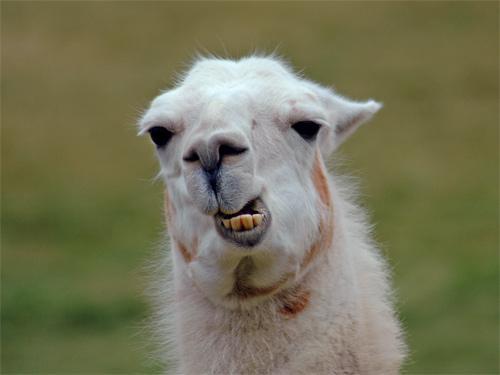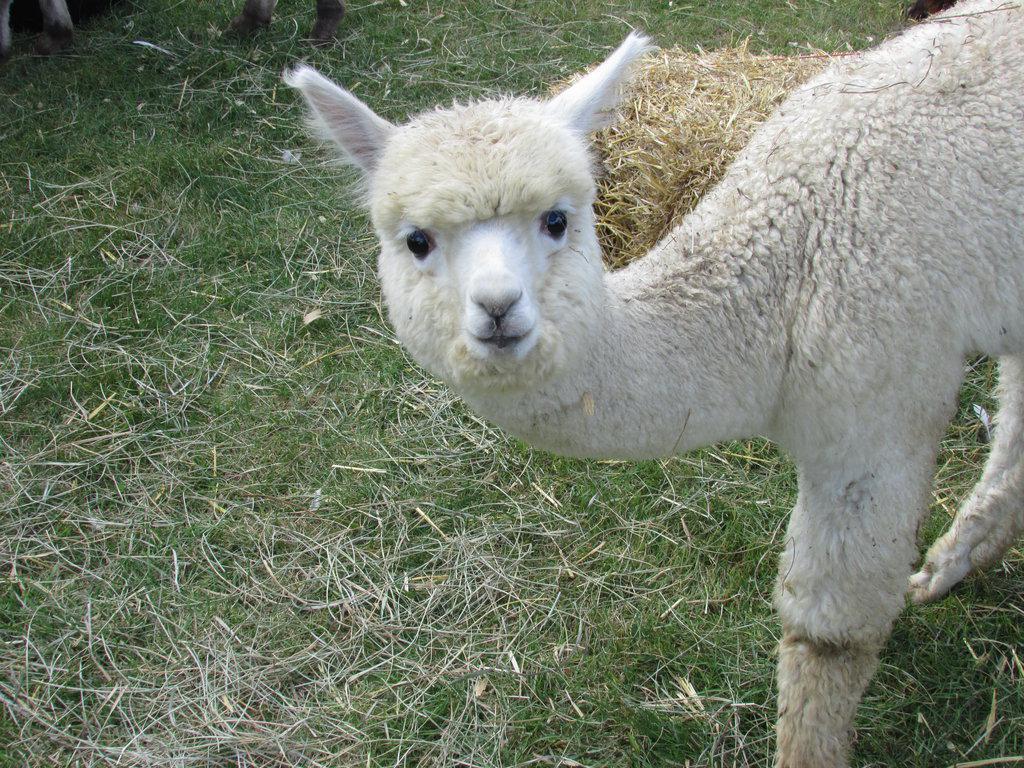The first image is the image on the left, the second image is the image on the right. Given the left and right images, does the statement "One image shows a forward-facing llama with projecting lower teeth, and the other image shows a forward-facing llama with woolly white hair on top of its head." hold true? Answer yes or no. Yes. The first image is the image on the left, the second image is the image on the right. Assess this claim about the two images: "there is a llama  with it's mouth open wide showing it's tongue and teeth". Correct or not? Answer yes or no. No. 